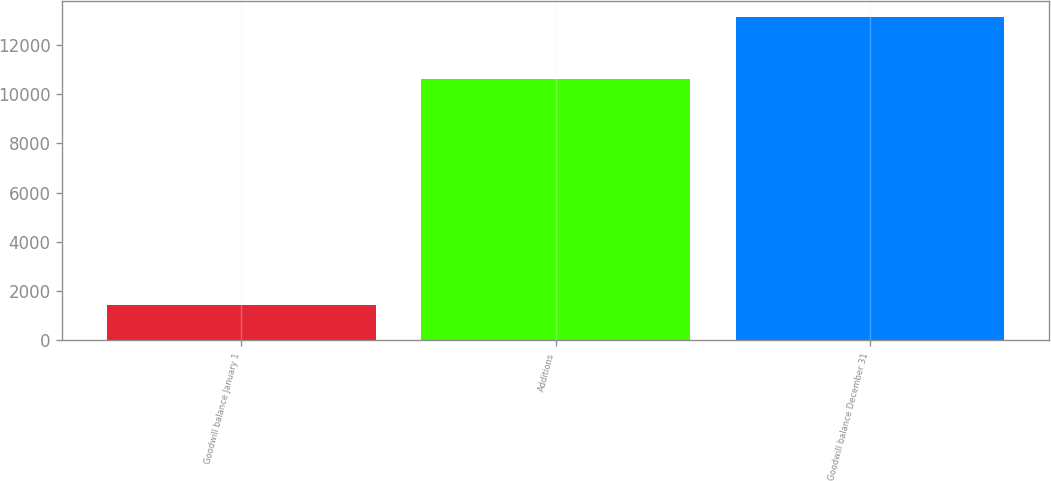Convert chart to OTSL. <chart><loc_0><loc_0><loc_500><loc_500><bar_chart><fcel>Goodwill balance January 1<fcel>Additions<fcel>Goodwill balance December 31<nl><fcel>1439<fcel>10599<fcel>13131.9<nl></chart> 